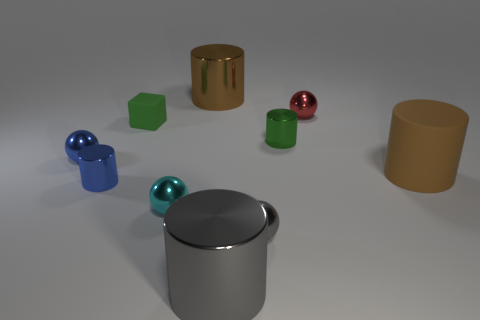There is a cylinder that is the same color as the tiny rubber cube; what is it made of?
Offer a terse response. Metal. There is a shiny cylinder that is on the right side of the large gray cylinder; is it the same color as the large rubber cylinder that is behind the tiny gray metallic sphere?
Your answer should be very brief. No. What number of gray objects are large cylinders or small blocks?
Give a very brief answer. 1. What number of gray matte spheres are the same size as the cube?
Provide a short and direct response. 0. Is the large brown thing behind the brown rubber object made of the same material as the small blue ball?
Offer a very short reply. Yes. There is a large brown object behind the red ball; are there any small rubber cubes behind it?
Your answer should be very brief. No. There is a tiny green object that is the same shape as the large gray metallic object; what is its material?
Make the answer very short. Metal. Are there more small cubes in front of the matte cube than shiny things in front of the blue metallic sphere?
Offer a very short reply. No. What shape is the big brown thing that is the same material as the tiny green cube?
Offer a terse response. Cylinder. Is the number of cyan balls that are behind the tiny blue metallic ball greater than the number of large rubber objects?
Your response must be concise. No. 